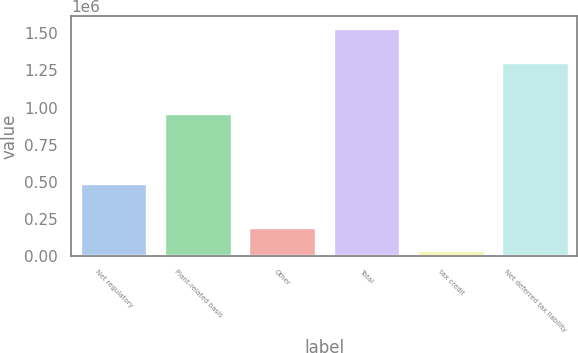Convert chart to OTSL. <chart><loc_0><loc_0><loc_500><loc_500><bar_chart><fcel>Net regulatory<fcel>Plant-related basis<fcel>Other<fcel>Total<fcel>tax credit<fcel>Net deferred tax liability<nl><fcel>493358<fcel>962100<fcel>190350<fcel>1.53926e+06<fcel>40471<fcel>1.30835e+06<nl></chart> 